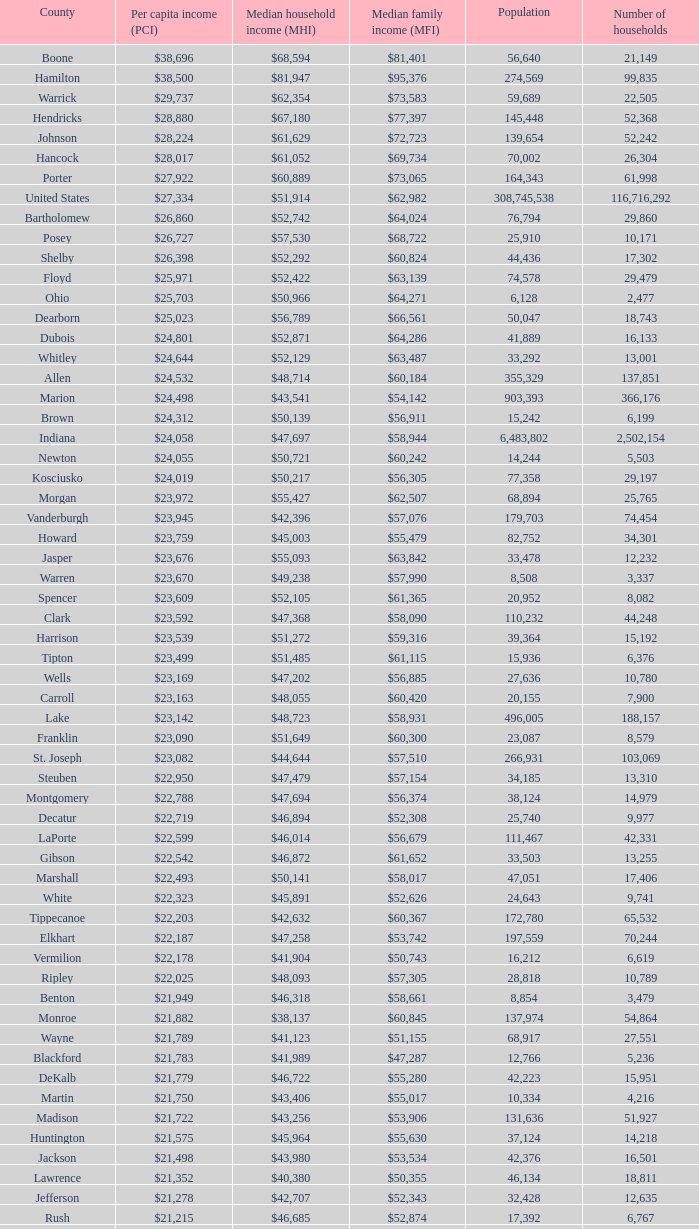What is the Median family income when the Median household income is $38,137? $60,845. 